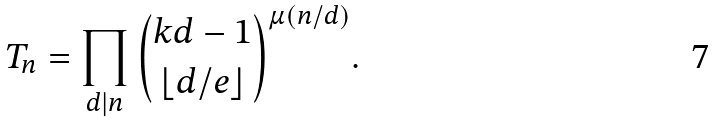<formula> <loc_0><loc_0><loc_500><loc_500>T _ { n } = \prod _ { d | n } \binom { k d - 1 } { \lfloor d / e \rfloor } ^ { \mu ( n / d ) } .</formula> 